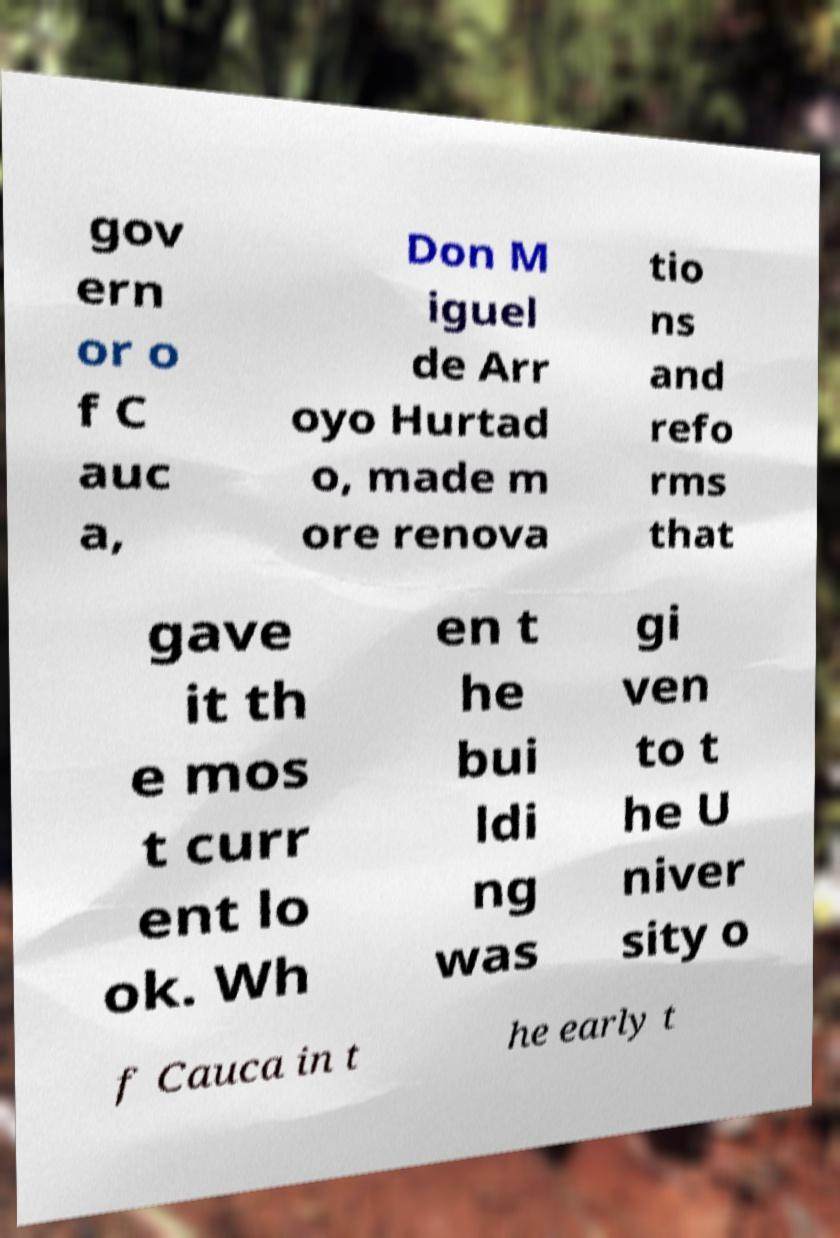Can you accurately transcribe the text from the provided image for me? gov ern or o f C auc a, Don M iguel de Arr oyo Hurtad o, made m ore renova tio ns and refo rms that gave it th e mos t curr ent lo ok. Wh en t he bui ldi ng was gi ven to t he U niver sity o f Cauca in t he early t 